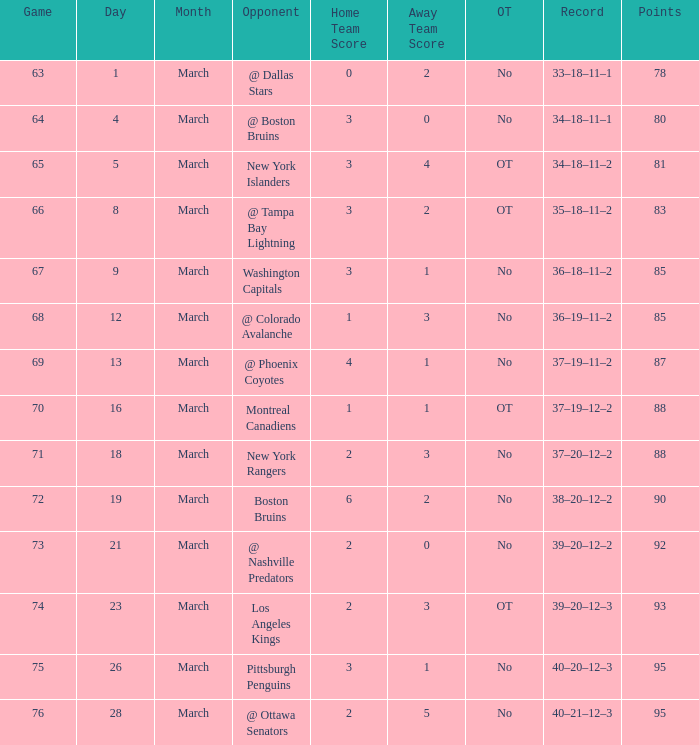Which Game is the highest one that has Points smaller than 92, and a Score of 1–3? 68.0. 